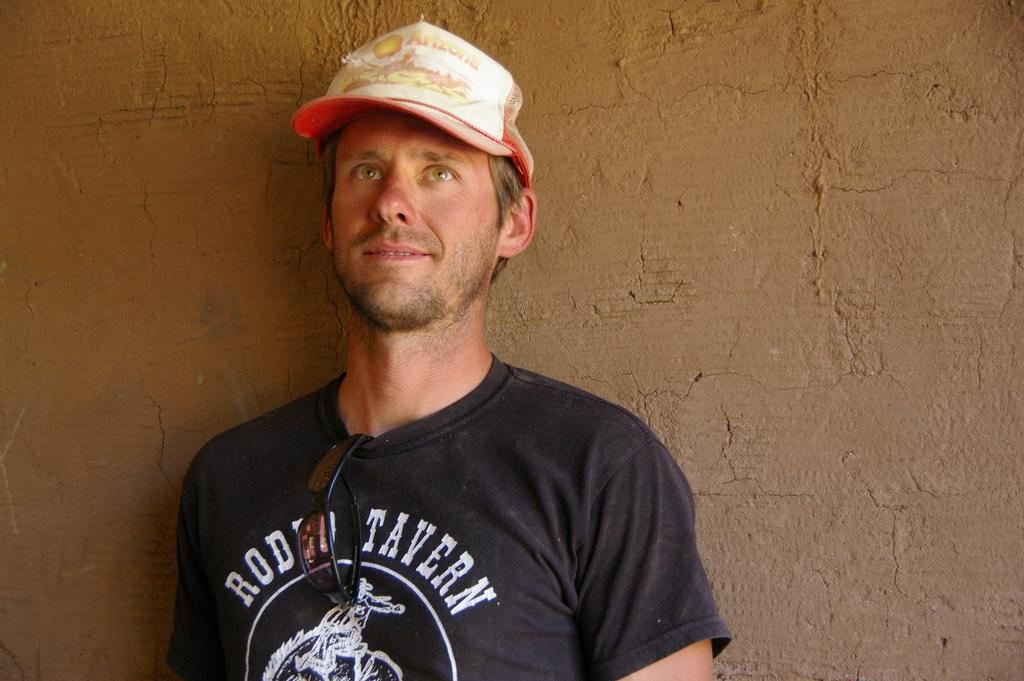Who is present in the image? There is a man in the image. What is the man doing in the image? The man is standing in the image. What accessories is the man wearing in the image? The man is wearing a cap, a t-shirt, and goggles in the image. What can be seen in the background of the image? There is a wall in the image. What type of egg is the man holding in the image? There is no egg present in the image. What is the man's interest in the image? The provided facts do not mention the man's interests, so we cannot determine his interest from the image. 